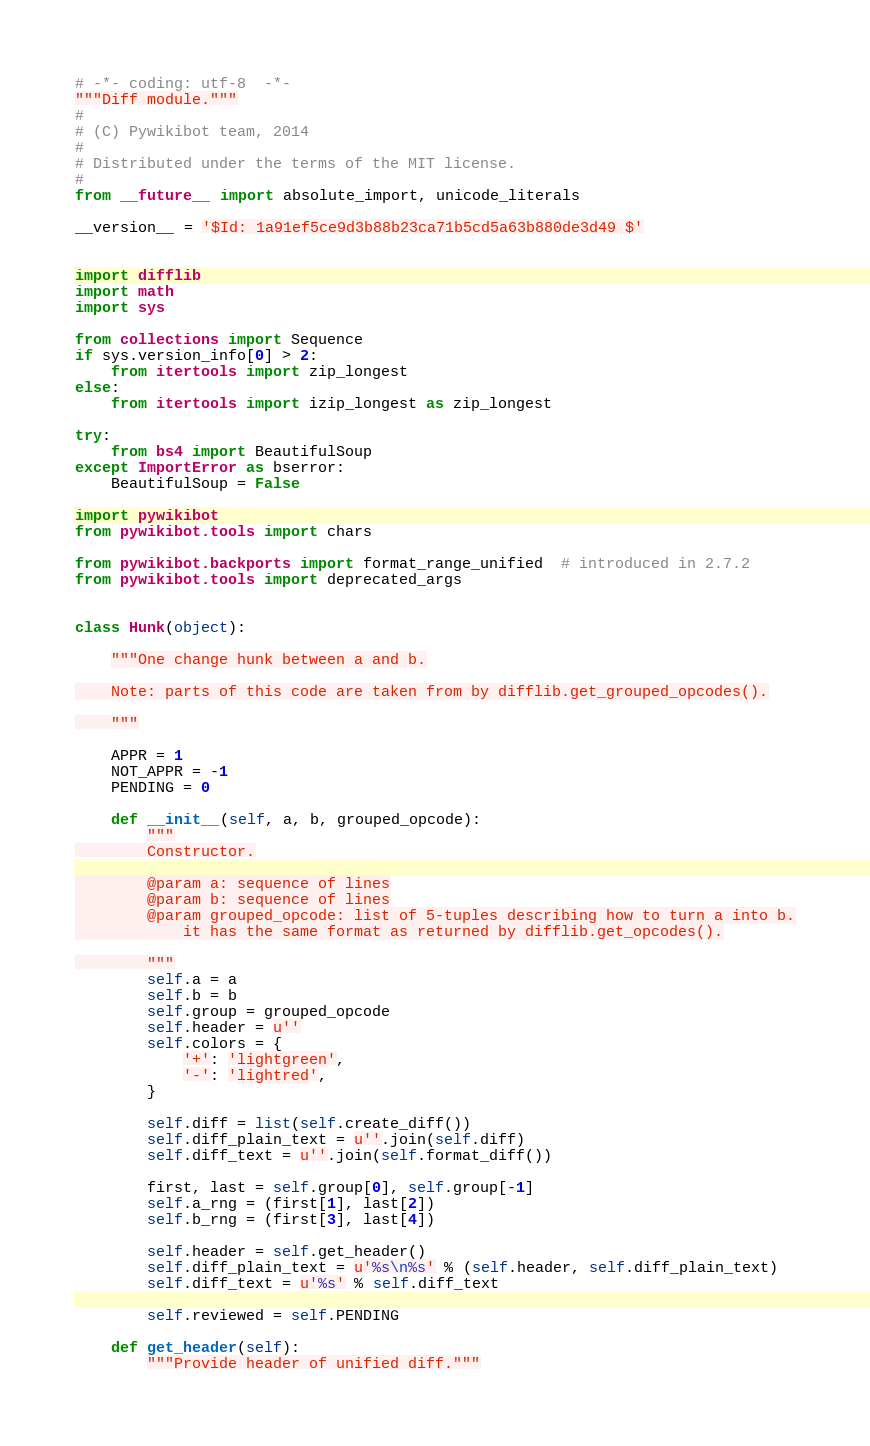<code> <loc_0><loc_0><loc_500><loc_500><_Python_># -*- coding: utf-8  -*-
"""Diff module."""
#
# (C) Pywikibot team, 2014
#
# Distributed under the terms of the MIT license.
#
from __future__ import absolute_import, unicode_literals

__version__ = '$Id: 1a91ef5ce9d3b88b23ca71b5cd5a63b880de3d49 $'


import difflib
import math
import sys

from collections import Sequence
if sys.version_info[0] > 2:
    from itertools import zip_longest
else:
    from itertools import izip_longest as zip_longest

try:
    from bs4 import BeautifulSoup
except ImportError as bserror:
    BeautifulSoup = False

import pywikibot
from pywikibot.tools import chars

from pywikibot.backports import format_range_unified  # introduced in 2.7.2
from pywikibot.tools import deprecated_args


class Hunk(object):

    """One change hunk between a and b.

    Note: parts of this code are taken from by difflib.get_grouped_opcodes().

    """

    APPR = 1
    NOT_APPR = -1
    PENDING = 0

    def __init__(self, a, b, grouped_opcode):
        """
        Constructor.

        @param a: sequence of lines
        @param b: sequence of lines
        @param grouped_opcode: list of 5-tuples describing how to turn a into b.
            it has the same format as returned by difflib.get_opcodes().

        """
        self.a = a
        self.b = b
        self.group = grouped_opcode
        self.header = u''
        self.colors = {
            '+': 'lightgreen',
            '-': 'lightred',
        }

        self.diff = list(self.create_diff())
        self.diff_plain_text = u''.join(self.diff)
        self.diff_text = u''.join(self.format_diff())

        first, last = self.group[0], self.group[-1]
        self.a_rng = (first[1], last[2])
        self.b_rng = (first[3], last[4])

        self.header = self.get_header()
        self.diff_plain_text = u'%s\n%s' % (self.header, self.diff_plain_text)
        self.diff_text = u'%s' % self.diff_text

        self.reviewed = self.PENDING

    def get_header(self):
        """Provide header of unified diff."""</code> 